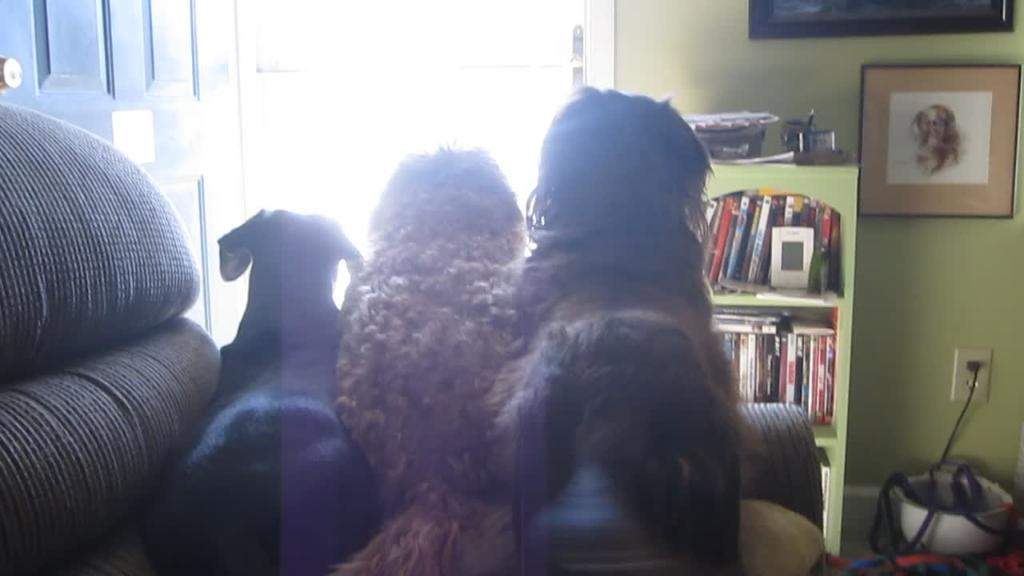How many dogs are on the sofa in the image? There are three dogs on the sofa in the image. What is in front of the sofa? There is a door and a books rack in front of the sofa. What can be seen on the wall in the image? There is a photo frame on the wall. What else is visible on the floor in the image? There are other objects on the floor. How many units of boot can be seen in the image? There are no boots present in the image. 